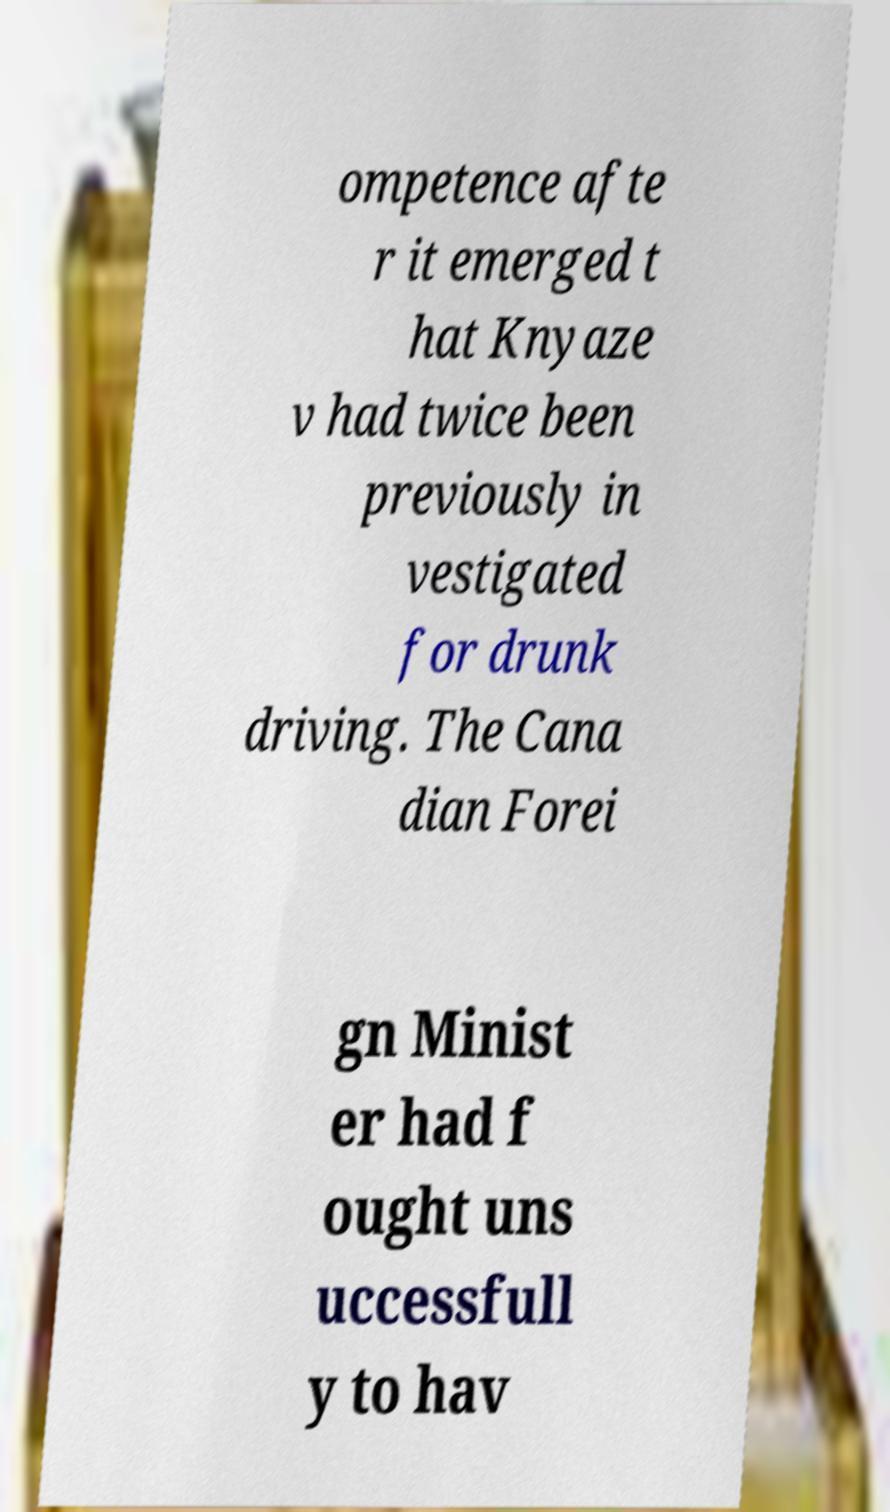I need the written content from this picture converted into text. Can you do that? ompetence afte r it emerged t hat Knyaze v had twice been previously in vestigated for drunk driving. The Cana dian Forei gn Minist er had f ought uns uccessfull y to hav 